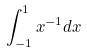Convert formula to latex. <formula><loc_0><loc_0><loc_500><loc_500>\int _ { - 1 } ^ { 1 } x ^ { - 1 } d x</formula> 